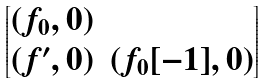Convert formula to latex. <formula><loc_0><loc_0><loc_500><loc_500>\begin{bmatrix} ( f _ { 0 } , 0 ) & \\ ( f ^ { \prime } , 0 ) & ( f _ { 0 } [ - 1 ] , 0 ) \end{bmatrix}</formula> 